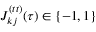Convert formula to latex. <formula><loc_0><loc_0><loc_500><loc_500>J _ { k j } ^ { ( t t ) } ( \tau ) \in \{ - 1 , 1 \}</formula> 